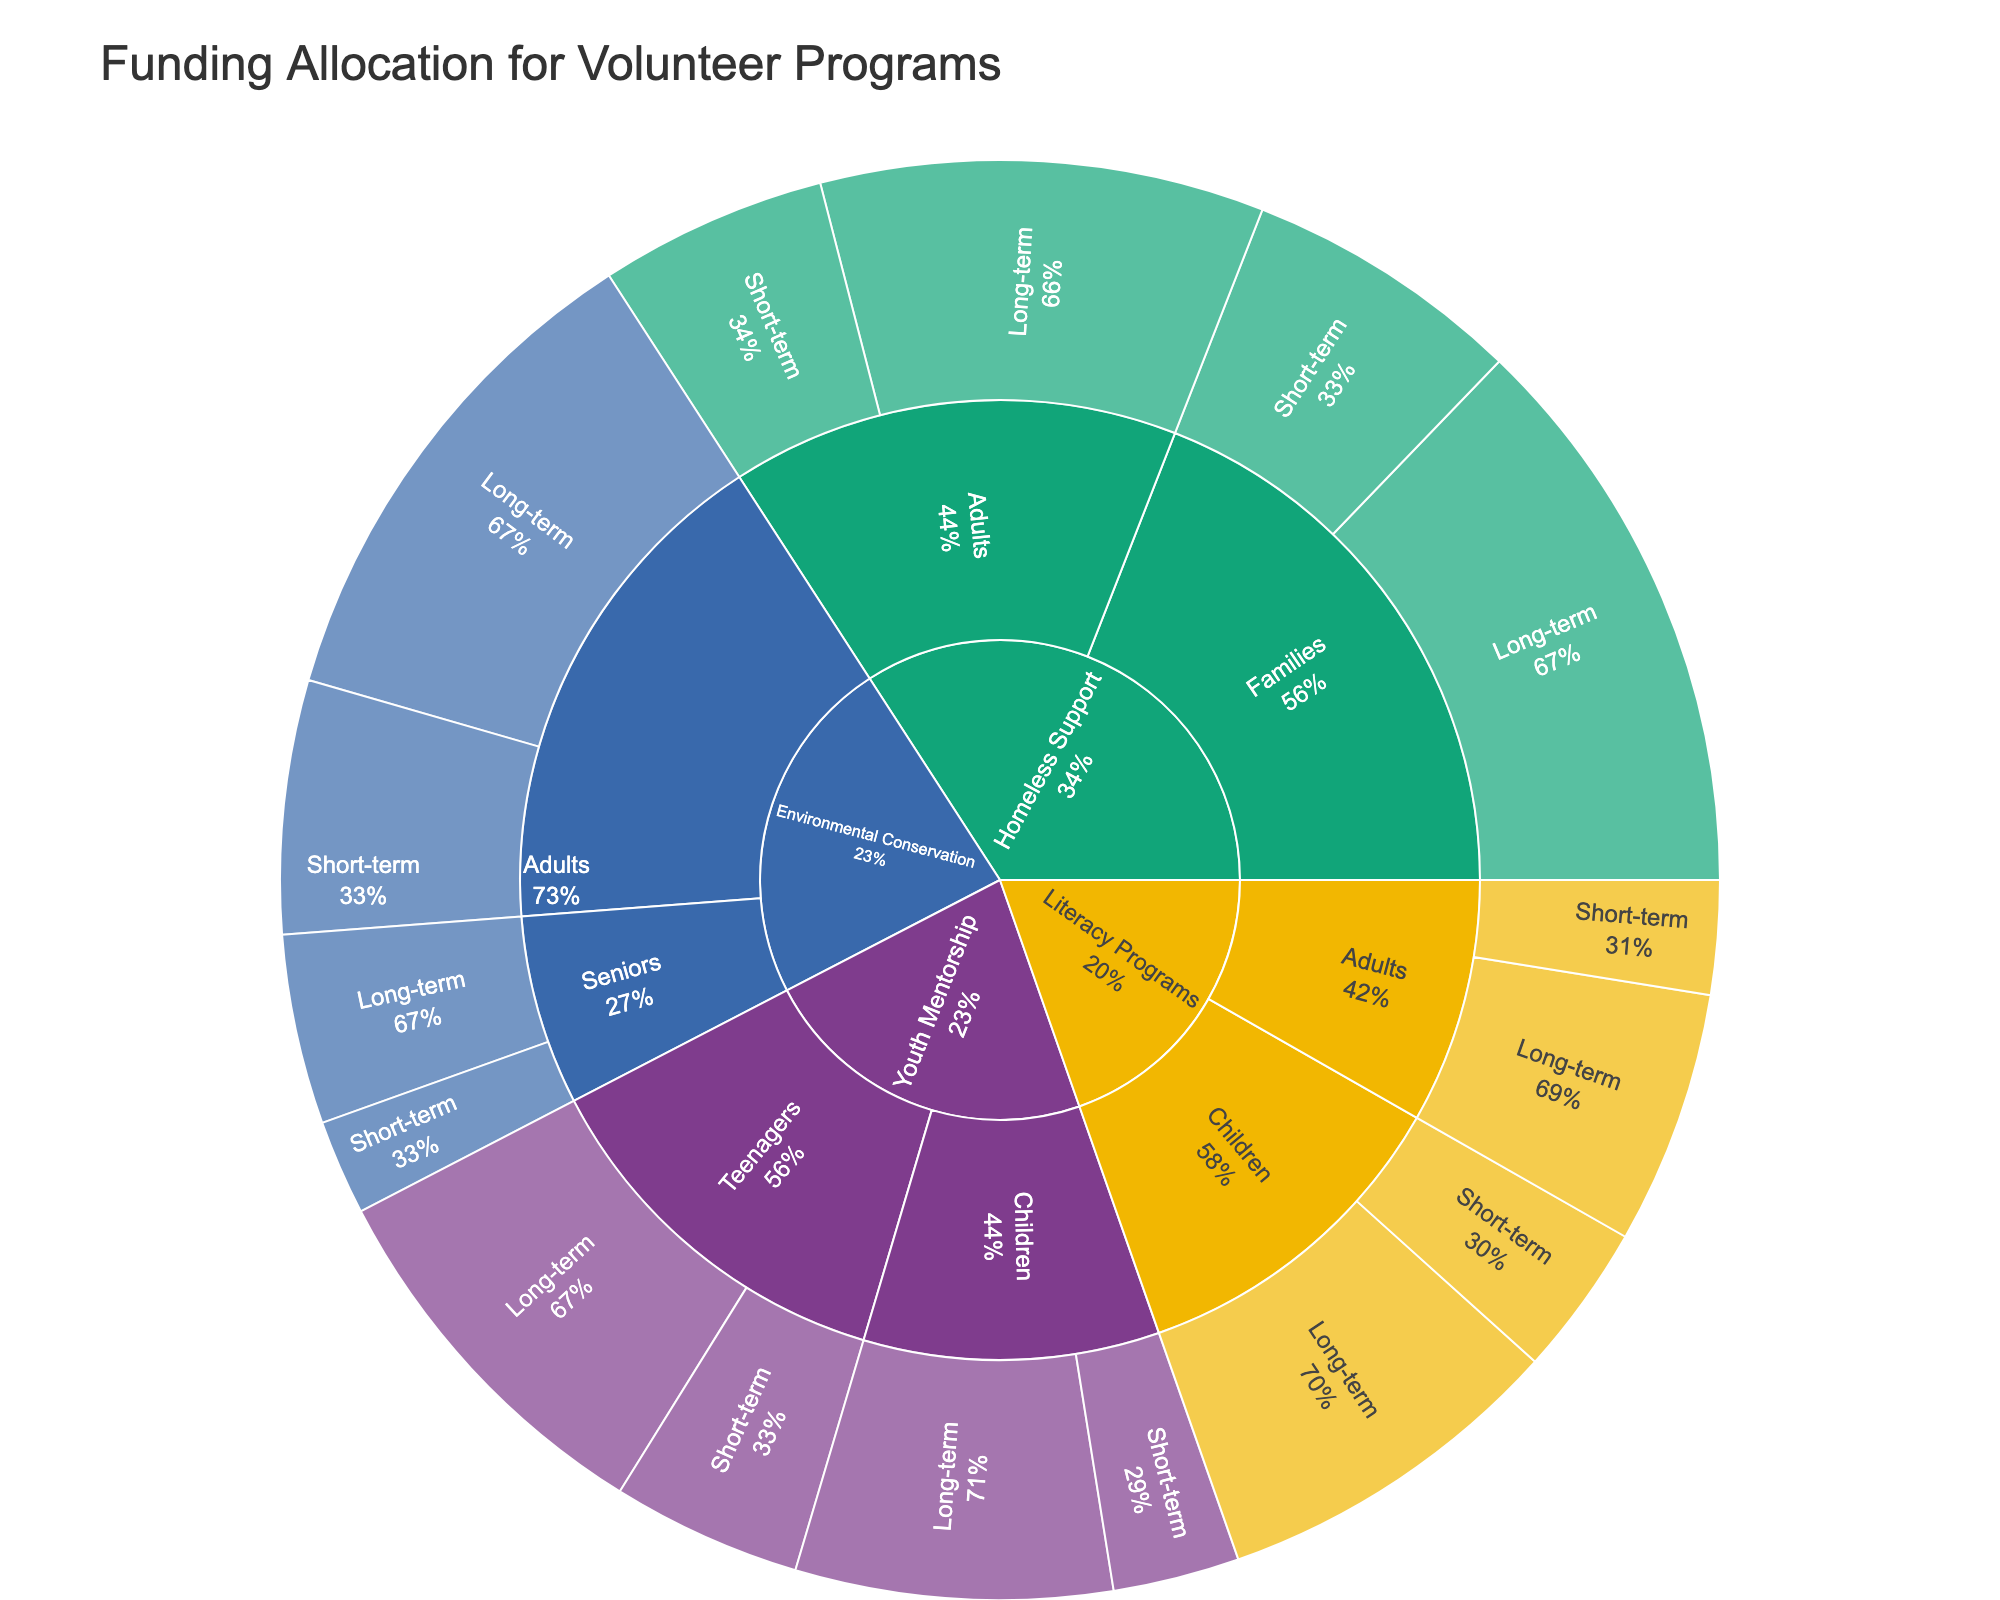what is the title of the figure? The title is typically found at the top of the Sunburst Plot and often includes a description of the data being visualized. For this plot, the title summarizes the content succinctly.
Answer: Funding Allocation for Volunteer Programs how many different implementation timelines are represented in the plot? Each "target demographic" category, and each "program type" under these demographics, can be broken down further into different implementation timelines: short-term and long-term.
Answer: 2 which program type has the highest total funding allocation? By summing the funding allocations of each program type across all target demographics and implementation timelines, we determine which has the highest total.
Answer: Homeless Support how much total funding is allocated to youth mentorship programs? Summing the funding allocations for all target demographics and implementation timelines under the Youth Mentorship program type provides the total.
Answer: 800,000 which target demographic within Literacy Programs has more funding? Compare the total funding allocation for each target demographic (Children, Adults) within the Literacy Programs by summing their respective short-term and long-term funding.
Answer: Children is the funding for children or adults higher in the Youth Mentorship program? Compare the sum of the funding allocations for Children and Adults, adding up the short-term and long-term values for each group under the Youth Mentorship program.
Answer: Children what percentage of total funding in Homeless Support is allocated to Families? Sum the funding for Families in Homeless Support (both short-term and long-term), then divide by the total funding for Homeless Support and multiply by 100 to get the percentage.
Answer: 47.45% which target demographic has the smallest funding allocation in Environmental Conservation? Compare the total funding allocations for Adults and Seniors in Environmental Conservation by summing their short-term and long-term funding.
Answer: Seniors how does long-term funding for Environmental Conservation compare to short-term funding? Sum the funding for Environmental Conservation programs categorized as long-term and compare to the sum of short-term funding for the same program type.
Answer: Long-term funding is higher which implementation timeline receives the most funding across all program types? Aggregate the funding allocations classified as short-term and long-term across all program types and compare the sums.
Answer: Long-term 